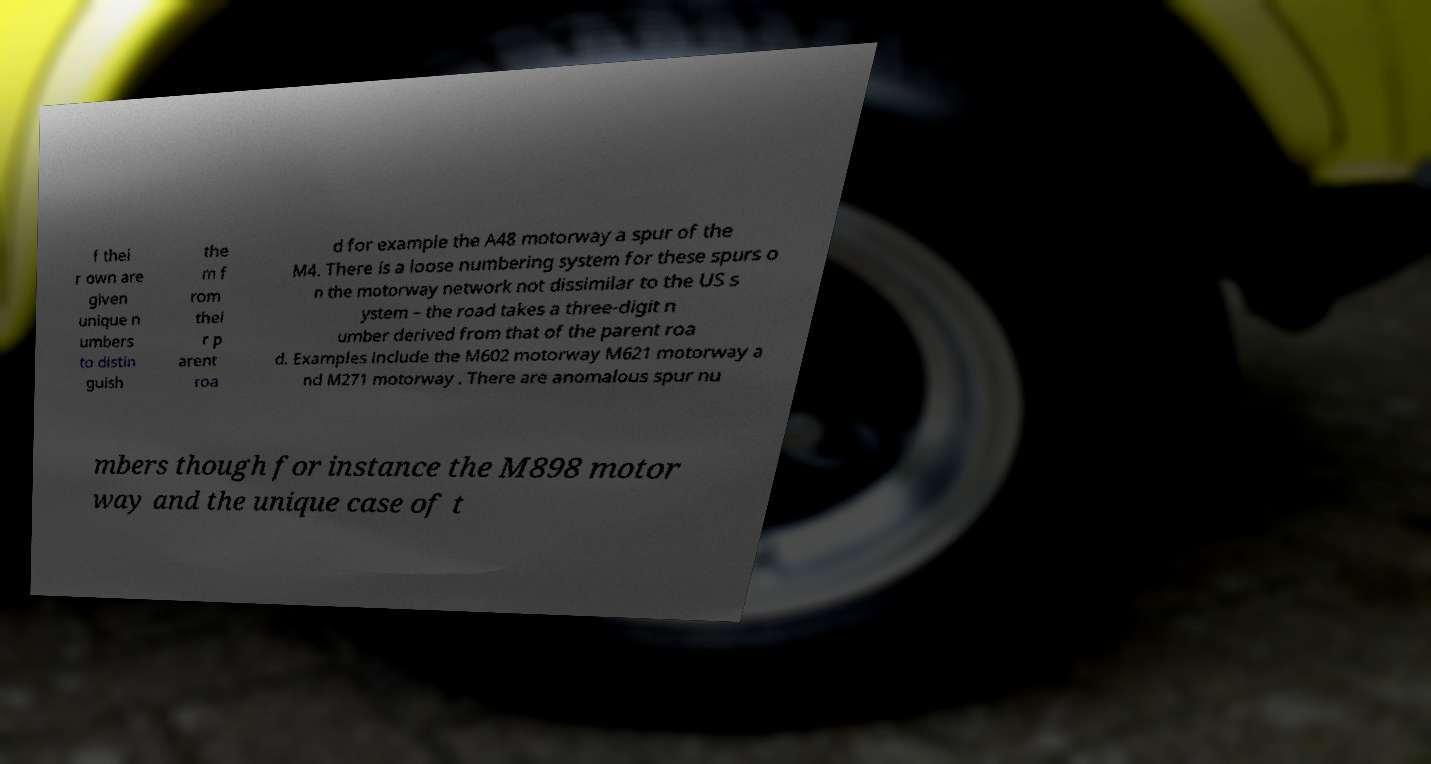Could you extract and type out the text from this image? f thei r own are given unique n umbers to distin guish the m f rom thei r p arent roa d for example the A48 motorway a spur of the M4. There is a loose numbering system for these spurs o n the motorway network not dissimilar to the US s ystem – the road takes a three-digit n umber derived from that of the parent roa d. Examples include the M602 motorway M621 motorway a nd M271 motorway . There are anomalous spur nu mbers though for instance the M898 motor way and the unique case of t 